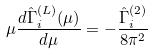Convert formula to latex. <formula><loc_0><loc_0><loc_500><loc_500>\mu \frac { d \hat { \Gamma } ^ { ( L ) } _ { i } ( \mu ) } { d \mu } = - \frac { \hat { \Gamma } ^ { ( 2 ) } _ { i } } { 8 \pi ^ { 2 } }</formula> 